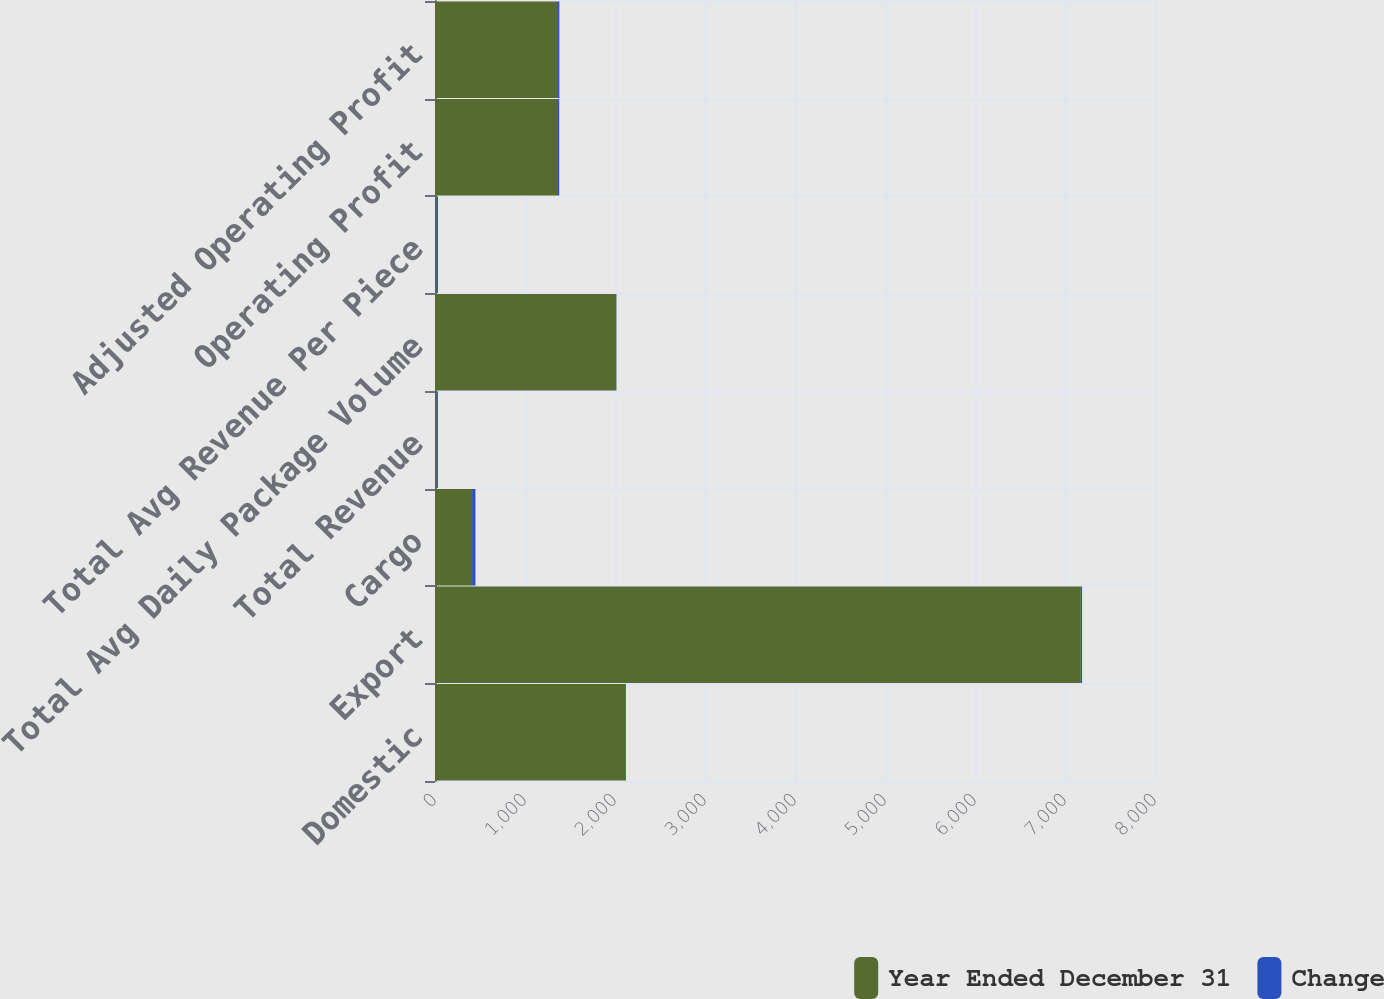Convert chart to OTSL. <chart><loc_0><loc_0><loc_500><loc_500><stacked_bar_chart><ecel><fcel>Domestic<fcel>Export<fcel>Cargo<fcel>Total Revenue<fcel>Total Avg Daily Package Volume<fcel>Total Avg Revenue Per Piece<fcel>Operating Profit<fcel>Adjusted Operating Profit<nl><fcel>Year Ended December 31<fcel>2111<fcel>7176<fcel>412<fcel>18.23<fcel>2014<fcel>18.23<fcel>1367<fcel>1367<nl><fcel>Change<fcel>9.9<fcel>13.5<fcel>37.1<fcel>14.1<fcel>2.6<fcel>15.2<fcel>13.5<fcel>14.9<nl></chart> 